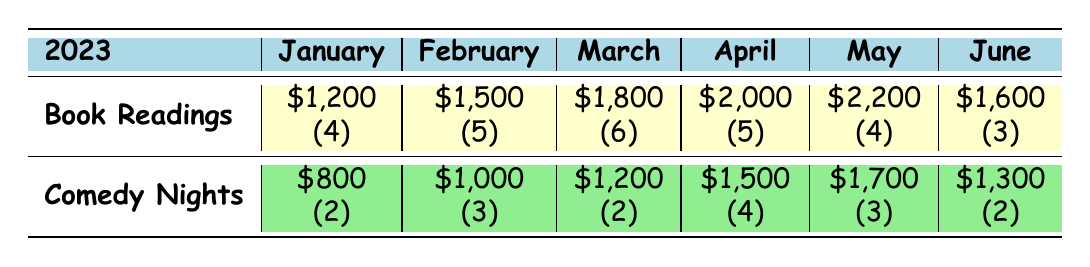What was the total revenue from Comedy Nights in January and February? The revenue for Comedy Nights in January is $800, and in February, it is $1,000. Adding these together gives $800 + $1,000 = $1,800.
Answer: $1,800 How many Book Readings were held in April? According to the table, the number of Book Readings in April is noted as (5), meaning there were 5 events.
Answer: 5 Which month had the highest revenue from Comedy Nights? By examining the revenue values for Comedy Nights, April shows the highest revenue at $1,500, followed by May at $1,700. Therefore, May is the month with the highest revenue.
Answer: May What was the average revenue from Book Readings over the first half of 2023? The revenue values for Book Readings from January to June are $1,200, $1,500, $1,800, $2,000, $2,200, and $1,600. Adding these yields $1,200 + $1,500 + $1,800 + $2,000 + $2,200 + $1,600 = $10,300. There are 6 months, so we divide by 6: $10,300 / 6 = $1,716.67.
Answer: $1,716.67 In March, how much more revenue did Book Readings generate than Comedy Nights? The revenue for Book Readings in March is $1,800, while Comedy Nights generated $1,200. The difference is $1,800 - $1,200 = $600.
Answer: $600 Did the number of Comedy Nights increase, decrease, or stay the same from April to May? The number of Comedy Nights in April is (4) and in May is (3). Since 4 is greater than 3, the number of Comedy Nights decreased from April to May.
Answer: Decreased What was the total number of events held across both types in June? In June, the number of Book Readings is (3) and Comedy Nights is (2). To find the total, we add these: 3 + 2 = 5 events total.
Answer: 5 Which event type consistently generated more revenue over the six months? Examining the revenue for both event types over the months, Book Readings have revenue values of $1,200, $1,500, $1,800, $2,000, $2,200, and $1,600, while Comedy Nights have values of $800, $1,000, $1,200, $1,500, $1,700, and $1,300. The totals for Book Readings ($10,300) are consistently higher than for Comedy Nights ($7,700).
Answer: Book Readings How did the revenue for Comedy Nights in June compare to that in March? The revenue for Comedy Nights in March is $1,200, and in June, it is $1,300. Since $1,300 > $1,200, the revenue in June is higher than in March.
Answer: Higher 